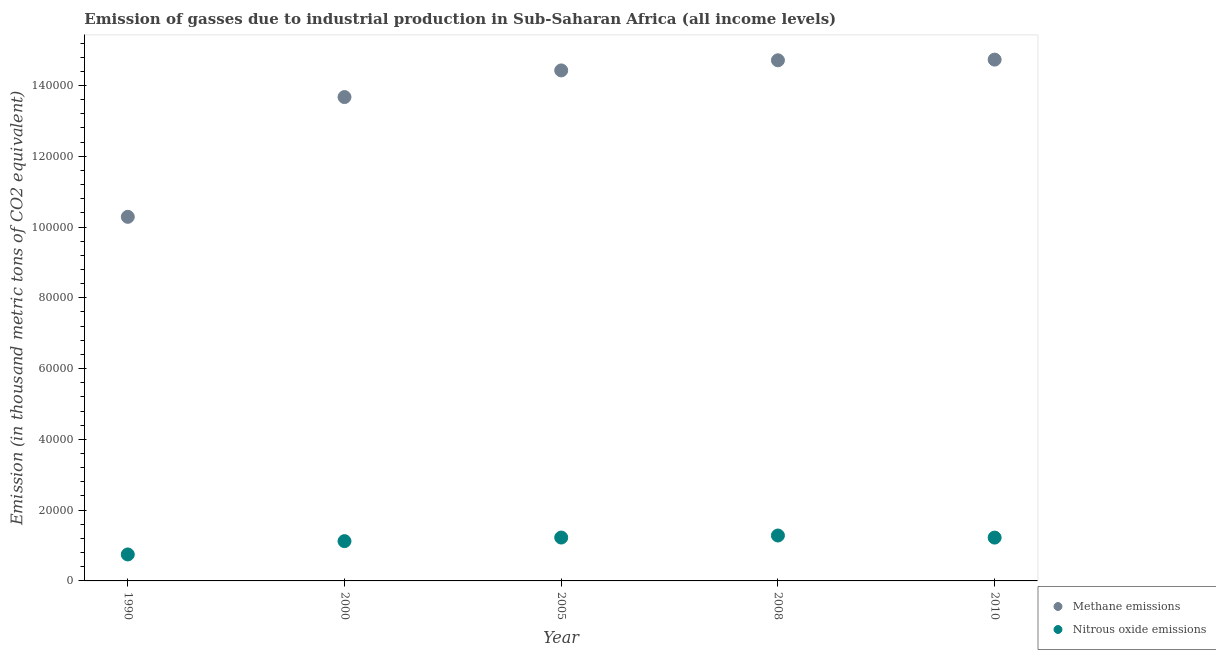How many different coloured dotlines are there?
Keep it short and to the point. 2. What is the amount of nitrous oxide emissions in 2008?
Ensure brevity in your answer.  1.28e+04. Across all years, what is the maximum amount of nitrous oxide emissions?
Offer a very short reply. 1.28e+04. Across all years, what is the minimum amount of nitrous oxide emissions?
Make the answer very short. 7482.3. In which year was the amount of nitrous oxide emissions maximum?
Your answer should be very brief. 2008. In which year was the amount of nitrous oxide emissions minimum?
Keep it short and to the point. 1990. What is the total amount of methane emissions in the graph?
Ensure brevity in your answer.  6.78e+05. What is the difference between the amount of methane emissions in 1990 and that in 2010?
Give a very brief answer. -4.44e+04. What is the difference between the amount of methane emissions in 1990 and the amount of nitrous oxide emissions in 2005?
Offer a very short reply. 9.06e+04. What is the average amount of methane emissions per year?
Keep it short and to the point. 1.36e+05. In the year 1990, what is the difference between the amount of nitrous oxide emissions and amount of methane emissions?
Your response must be concise. -9.54e+04. What is the ratio of the amount of nitrous oxide emissions in 1990 to that in 2010?
Make the answer very short. 0.61. Is the difference between the amount of nitrous oxide emissions in 1990 and 2010 greater than the difference between the amount of methane emissions in 1990 and 2010?
Your response must be concise. Yes. What is the difference between the highest and the second highest amount of methane emissions?
Make the answer very short. 192.3. What is the difference between the highest and the lowest amount of nitrous oxide emissions?
Give a very brief answer. 5351.1. In how many years, is the amount of nitrous oxide emissions greater than the average amount of nitrous oxide emissions taken over all years?
Your answer should be very brief. 4. Is the sum of the amount of methane emissions in 2005 and 2010 greater than the maximum amount of nitrous oxide emissions across all years?
Ensure brevity in your answer.  Yes. Is the amount of nitrous oxide emissions strictly greater than the amount of methane emissions over the years?
Give a very brief answer. No. Is the amount of methane emissions strictly less than the amount of nitrous oxide emissions over the years?
Give a very brief answer. No. How many years are there in the graph?
Provide a succinct answer. 5. Does the graph contain any zero values?
Offer a very short reply. No. How many legend labels are there?
Give a very brief answer. 2. What is the title of the graph?
Offer a very short reply. Emission of gasses due to industrial production in Sub-Saharan Africa (all income levels). What is the label or title of the X-axis?
Your response must be concise. Year. What is the label or title of the Y-axis?
Your response must be concise. Emission (in thousand metric tons of CO2 equivalent). What is the Emission (in thousand metric tons of CO2 equivalent) of Methane emissions in 1990?
Ensure brevity in your answer.  1.03e+05. What is the Emission (in thousand metric tons of CO2 equivalent) of Nitrous oxide emissions in 1990?
Offer a very short reply. 7482.3. What is the Emission (in thousand metric tons of CO2 equivalent) of Methane emissions in 2000?
Give a very brief answer. 1.37e+05. What is the Emission (in thousand metric tons of CO2 equivalent) in Nitrous oxide emissions in 2000?
Offer a very short reply. 1.12e+04. What is the Emission (in thousand metric tons of CO2 equivalent) in Methane emissions in 2005?
Keep it short and to the point. 1.44e+05. What is the Emission (in thousand metric tons of CO2 equivalent) of Nitrous oxide emissions in 2005?
Give a very brief answer. 1.23e+04. What is the Emission (in thousand metric tons of CO2 equivalent) of Methane emissions in 2008?
Make the answer very short. 1.47e+05. What is the Emission (in thousand metric tons of CO2 equivalent) in Nitrous oxide emissions in 2008?
Ensure brevity in your answer.  1.28e+04. What is the Emission (in thousand metric tons of CO2 equivalent) in Methane emissions in 2010?
Your answer should be very brief. 1.47e+05. What is the Emission (in thousand metric tons of CO2 equivalent) of Nitrous oxide emissions in 2010?
Provide a succinct answer. 1.22e+04. Across all years, what is the maximum Emission (in thousand metric tons of CO2 equivalent) in Methane emissions?
Ensure brevity in your answer.  1.47e+05. Across all years, what is the maximum Emission (in thousand metric tons of CO2 equivalent) in Nitrous oxide emissions?
Provide a short and direct response. 1.28e+04. Across all years, what is the minimum Emission (in thousand metric tons of CO2 equivalent) in Methane emissions?
Your answer should be very brief. 1.03e+05. Across all years, what is the minimum Emission (in thousand metric tons of CO2 equivalent) in Nitrous oxide emissions?
Your answer should be compact. 7482.3. What is the total Emission (in thousand metric tons of CO2 equivalent) in Methane emissions in the graph?
Ensure brevity in your answer.  6.78e+05. What is the total Emission (in thousand metric tons of CO2 equivalent) in Nitrous oxide emissions in the graph?
Your answer should be compact. 5.61e+04. What is the difference between the Emission (in thousand metric tons of CO2 equivalent) in Methane emissions in 1990 and that in 2000?
Keep it short and to the point. -3.38e+04. What is the difference between the Emission (in thousand metric tons of CO2 equivalent) in Nitrous oxide emissions in 1990 and that in 2000?
Provide a succinct answer. -3756.4. What is the difference between the Emission (in thousand metric tons of CO2 equivalent) of Methane emissions in 1990 and that in 2005?
Ensure brevity in your answer.  -4.14e+04. What is the difference between the Emission (in thousand metric tons of CO2 equivalent) of Nitrous oxide emissions in 1990 and that in 2005?
Your answer should be very brief. -4774.5. What is the difference between the Emission (in thousand metric tons of CO2 equivalent) in Methane emissions in 1990 and that in 2008?
Offer a terse response. -4.42e+04. What is the difference between the Emission (in thousand metric tons of CO2 equivalent) of Nitrous oxide emissions in 1990 and that in 2008?
Your response must be concise. -5351.1. What is the difference between the Emission (in thousand metric tons of CO2 equivalent) in Methane emissions in 1990 and that in 2010?
Your answer should be very brief. -4.44e+04. What is the difference between the Emission (in thousand metric tons of CO2 equivalent) in Nitrous oxide emissions in 1990 and that in 2010?
Give a very brief answer. -4759.9. What is the difference between the Emission (in thousand metric tons of CO2 equivalent) in Methane emissions in 2000 and that in 2005?
Provide a short and direct response. -7528.2. What is the difference between the Emission (in thousand metric tons of CO2 equivalent) in Nitrous oxide emissions in 2000 and that in 2005?
Make the answer very short. -1018.1. What is the difference between the Emission (in thousand metric tons of CO2 equivalent) of Methane emissions in 2000 and that in 2008?
Keep it short and to the point. -1.04e+04. What is the difference between the Emission (in thousand metric tons of CO2 equivalent) of Nitrous oxide emissions in 2000 and that in 2008?
Keep it short and to the point. -1594.7. What is the difference between the Emission (in thousand metric tons of CO2 equivalent) of Methane emissions in 2000 and that in 2010?
Your response must be concise. -1.06e+04. What is the difference between the Emission (in thousand metric tons of CO2 equivalent) of Nitrous oxide emissions in 2000 and that in 2010?
Give a very brief answer. -1003.5. What is the difference between the Emission (in thousand metric tons of CO2 equivalent) of Methane emissions in 2005 and that in 2008?
Provide a short and direct response. -2859.6. What is the difference between the Emission (in thousand metric tons of CO2 equivalent) of Nitrous oxide emissions in 2005 and that in 2008?
Keep it short and to the point. -576.6. What is the difference between the Emission (in thousand metric tons of CO2 equivalent) of Methane emissions in 2005 and that in 2010?
Your response must be concise. -3051.9. What is the difference between the Emission (in thousand metric tons of CO2 equivalent) of Nitrous oxide emissions in 2005 and that in 2010?
Offer a terse response. 14.6. What is the difference between the Emission (in thousand metric tons of CO2 equivalent) of Methane emissions in 2008 and that in 2010?
Ensure brevity in your answer.  -192.3. What is the difference between the Emission (in thousand metric tons of CO2 equivalent) of Nitrous oxide emissions in 2008 and that in 2010?
Provide a succinct answer. 591.2. What is the difference between the Emission (in thousand metric tons of CO2 equivalent) of Methane emissions in 1990 and the Emission (in thousand metric tons of CO2 equivalent) of Nitrous oxide emissions in 2000?
Your answer should be very brief. 9.16e+04. What is the difference between the Emission (in thousand metric tons of CO2 equivalent) of Methane emissions in 1990 and the Emission (in thousand metric tons of CO2 equivalent) of Nitrous oxide emissions in 2005?
Ensure brevity in your answer.  9.06e+04. What is the difference between the Emission (in thousand metric tons of CO2 equivalent) of Methane emissions in 1990 and the Emission (in thousand metric tons of CO2 equivalent) of Nitrous oxide emissions in 2008?
Give a very brief answer. 9.00e+04. What is the difference between the Emission (in thousand metric tons of CO2 equivalent) in Methane emissions in 1990 and the Emission (in thousand metric tons of CO2 equivalent) in Nitrous oxide emissions in 2010?
Make the answer very short. 9.06e+04. What is the difference between the Emission (in thousand metric tons of CO2 equivalent) in Methane emissions in 2000 and the Emission (in thousand metric tons of CO2 equivalent) in Nitrous oxide emissions in 2005?
Keep it short and to the point. 1.24e+05. What is the difference between the Emission (in thousand metric tons of CO2 equivalent) of Methane emissions in 2000 and the Emission (in thousand metric tons of CO2 equivalent) of Nitrous oxide emissions in 2008?
Make the answer very short. 1.24e+05. What is the difference between the Emission (in thousand metric tons of CO2 equivalent) of Methane emissions in 2000 and the Emission (in thousand metric tons of CO2 equivalent) of Nitrous oxide emissions in 2010?
Make the answer very short. 1.24e+05. What is the difference between the Emission (in thousand metric tons of CO2 equivalent) in Methane emissions in 2005 and the Emission (in thousand metric tons of CO2 equivalent) in Nitrous oxide emissions in 2008?
Provide a succinct answer. 1.31e+05. What is the difference between the Emission (in thousand metric tons of CO2 equivalent) of Methane emissions in 2005 and the Emission (in thousand metric tons of CO2 equivalent) of Nitrous oxide emissions in 2010?
Your answer should be compact. 1.32e+05. What is the difference between the Emission (in thousand metric tons of CO2 equivalent) of Methane emissions in 2008 and the Emission (in thousand metric tons of CO2 equivalent) of Nitrous oxide emissions in 2010?
Offer a terse response. 1.35e+05. What is the average Emission (in thousand metric tons of CO2 equivalent) of Methane emissions per year?
Give a very brief answer. 1.36e+05. What is the average Emission (in thousand metric tons of CO2 equivalent) of Nitrous oxide emissions per year?
Provide a short and direct response. 1.12e+04. In the year 1990, what is the difference between the Emission (in thousand metric tons of CO2 equivalent) in Methane emissions and Emission (in thousand metric tons of CO2 equivalent) in Nitrous oxide emissions?
Keep it short and to the point. 9.54e+04. In the year 2000, what is the difference between the Emission (in thousand metric tons of CO2 equivalent) of Methane emissions and Emission (in thousand metric tons of CO2 equivalent) of Nitrous oxide emissions?
Give a very brief answer. 1.25e+05. In the year 2005, what is the difference between the Emission (in thousand metric tons of CO2 equivalent) of Methane emissions and Emission (in thousand metric tons of CO2 equivalent) of Nitrous oxide emissions?
Provide a short and direct response. 1.32e+05. In the year 2008, what is the difference between the Emission (in thousand metric tons of CO2 equivalent) of Methane emissions and Emission (in thousand metric tons of CO2 equivalent) of Nitrous oxide emissions?
Your response must be concise. 1.34e+05. In the year 2010, what is the difference between the Emission (in thousand metric tons of CO2 equivalent) in Methane emissions and Emission (in thousand metric tons of CO2 equivalent) in Nitrous oxide emissions?
Your answer should be compact. 1.35e+05. What is the ratio of the Emission (in thousand metric tons of CO2 equivalent) of Methane emissions in 1990 to that in 2000?
Provide a short and direct response. 0.75. What is the ratio of the Emission (in thousand metric tons of CO2 equivalent) of Nitrous oxide emissions in 1990 to that in 2000?
Your answer should be very brief. 0.67. What is the ratio of the Emission (in thousand metric tons of CO2 equivalent) in Methane emissions in 1990 to that in 2005?
Make the answer very short. 0.71. What is the ratio of the Emission (in thousand metric tons of CO2 equivalent) in Nitrous oxide emissions in 1990 to that in 2005?
Ensure brevity in your answer.  0.61. What is the ratio of the Emission (in thousand metric tons of CO2 equivalent) of Methane emissions in 1990 to that in 2008?
Your answer should be very brief. 0.7. What is the ratio of the Emission (in thousand metric tons of CO2 equivalent) in Nitrous oxide emissions in 1990 to that in 2008?
Offer a terse response. 0.58. What is the ratio of the Emission (in thousand metric tons of CO2 equivalent) in Methane emissions in 1990 to that in 2010?
Provide a succinct answer. 0.7. What is the ratio of the Emission (in thousand metric tons of CO2 equivalent) of Nitrous oxide emissions in 1990 to that in 2010?
Your response must be concise. 0.61. What is the ratio of the Emission (in thousand metric tons of CO2 equivalent) of Methane emissions in 2000 to that in 2005?
Provide a succinct answer. 0.95. What is the ratio of the Emission (in thousand metric tons of CO2 equivalent) in Nitrous oxide emissions in 2000 to that in 2005?
Your answer should be very brief. 0.92. What is the ratio of the Emission (in thousand metric tons of CO2 equivalent) in Methane emissions in 2000 to that in 2008?
Provide a succinct answer. 0.93. What is the ratio of the Emission (in thousand metric tons of CO2 equivalent) of Nitrous oxide emissions in 2000 to that in 2008?
Provide a short and direct response. 0.88. What is the ratio of the Emission (in thousand metric tons of CO2 equivalent) of Methane emissions in 2000 to that in 2010?
Provide a succinct answer. 0.93. What is the ratio of the Emission (in thousand metric tons of CO2 equivalent) of Nitrous oxide emissions in 2000 to that in 2010?
Your response must be concise. 0.92. What is the ratio of the Emission (in thousand metric tons of CO2 equivalent) in Methane emissions in 2005 to that in 2008?
Keep it short and to the point. 0.98. What is the ratio of the Emission (in thousand metric tons of CO2 equivalent) of Nitrous oxide emissions in 2005 to that in 2008?
Provide a succinct answer. 0.96. What is the ratio of the Emission (in thousand metric tons of CO2 equivalent) of Methane emissions in 2005 to that in 2010?
Provide a succinct answer. 0.98. What is the ratio of the Emission (in thousand metric tons of CO2 equivalent) in Methane emissions in 2008 to that in 2010?
Keep it short and to the point. 1. What is the ratio of the Emission (in thousand metric tons of CO2 equivalent) in Nitrous oxide emissions in 2008 to that in 2010?
Provide a succinct answer. 1.05. What is the difference between the highest and the second highest Emission (in thousand metric tons of CO2 equivalent) in Methane emissions?
Make the answer very short. 192.3. What is the difference between the highest and the second highest Emission (in thousand metric tons of CO2 equivalent) in Nitrous oxide emissions?
Give a very brief answer. 576.6. What is the difference between the highest and the lowest Emission (in thousand metric tons of CO2 equivalent) in Methane emissions?
Your answer should be compact. 4.44e+04. What is the difference between the highest and the lowest Emission (in thousand metric tons of CO2 equivalent) of Nitrous oxide emissions?
Provide a succinct answer. 5351.1. 